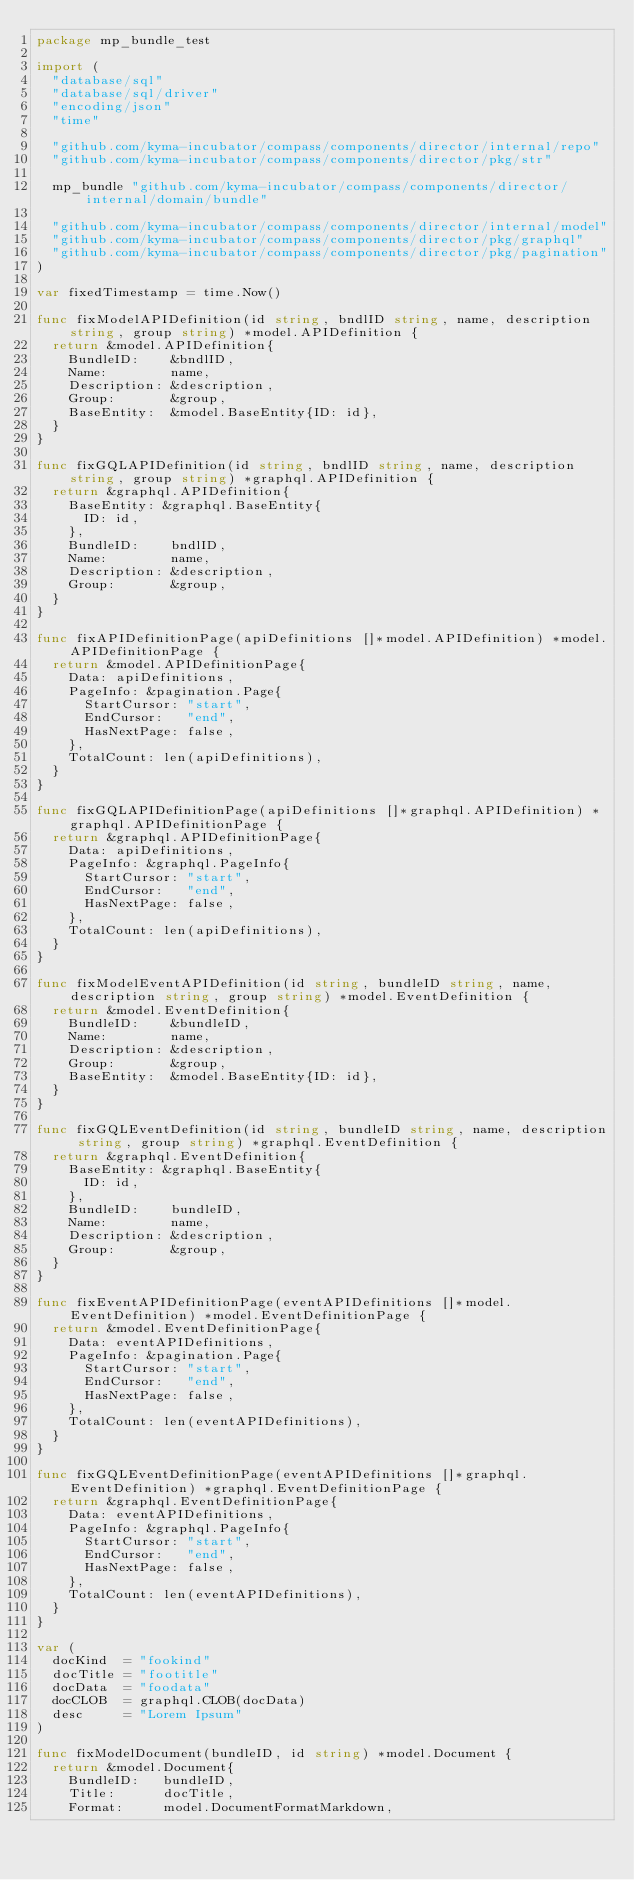Convert code to text. <code><loc_0><loc_0><loc_500><loc_500><_Go_>package mp_bundle_test

import (
	"database/sql"
	"database/sql/driver"
	"encoding/json"
	"time"

	"github.com/kyma-incubator/compass/components/director/internal/repo"
	"github.com/kyma-incubator/compass/components/director/pkg/str"

	mp_bundle "github.com/kyma-incubator/compass/components/director/internal/domain/bundle"

	"github.com/kyma-incubator/compass/components/director/internal/model"
	"github.com/kyma-incubator/compass/components/director/pkg/graphql"
	"github.com/kyma-incubator/compass/components/director/pkg/pagination"
)

var fixedTimestamp = time.Now()

func fixModelAPIDefinition(id string, bndlID string, name, description string, group string) *model.APIDefinition {
	return &model.APIDefinition{
		BundleID:    &bndlID,
		Name:        name,
		Description: &description,
		Group:       &group,
		BaseEntity:  &model.BaseEntity{ID: id},
	}
}

func fixGQLAPIDefinition(id string, bndlID string, name, description string, group string) *graphql.APIDefinition {
	return &graphql.APIDefinition{
		BaseEntity: &graphql.BaseEntity{
			ID: id,
		},
		BundleID:    bndlID,
		Name:        name,
		Description: &description,
		Group:       &group,
	}
}

func fixAPIDefinitionPage(apiDefinitions []*model.APIDefinition) *model.APIDefinitionPage {
	return &model.APIDefinitionPage{
		Data: apiDefinitions,
		PageInfo: &pagination.Page{
			StartCursor: "start",
			EndCursor:   "end",
			HasNextPage: false,
		},
		TotalCount: len(apiDefinitions),
	}
}

func fixGQLAPIDefinitionPage(apiDefinitions []*graphql.APIDefinition) *graphql.APIDefinitionPage {
	return &graphql.APIDefinitionPage{
		Data: apiDefinitions,
		PageInfo: &graphql.PageInfo{
			StartCursor: "start",
			EndCursor:   "end",
			HasNextPage: false,
		},
		TotalCount: len(apiDefinitions),
	}
}

func fixModelEventAPIDefinition(id string, bundleID string, name, description string, group string) *model.EventDefinition {
	return &model.EventDefinition{
		BundleID:    &bundleID,
		Name:        name,
		Description: &description,
		Group:       &group,
		BaseEntity:  &model.BaseEntity{ID: id},
	}
}

func fixGQLEventDefinition(id string, bundleID string, name, description string, group string) *graphql.EventDefinition {
	return &graphql.EventDefinition{
		BaseEntity: &graphql.BaseEntity{
			ID: id,
		},
		BundleID:    bundleID,
		Name:        name,
		Description: &description,
		Group:       &group,
	}
}

func fixEventAPIDefinitionPage(eventAPIDefinitions []*model.EventDefinition) *model.EventDefinitionPage {
	return &model.EventDefinitionPage{
		Data: eventAPIDefinitions,
		PageInfo: &pagination.Page{
			StartCursor: "start",
			EndCursor:   "end",
			HasNextPage: false,
		},
		TotalCount: len(eventAPIDefinitions),
	}
}

func fixGQLEventDefinitionPage(eventAPIDefinitions []*graphql.EventDefinition) *graphql.EventDefinitionPage {
	return &graphql.EventDefinitionPage{
		Data: eventAPIDefinitions,
		PageInfo: &graphql.PageInfo{
			StartCursor: "start",
			EndCursor:   "end",
			HasNextPage: false,
		},
		TotalCount: len(eventAPIDefinitions),
	}
}

var (
	docKind  = "fookind"
	docTitle = "footitle"
	docData  = "foodata"
	docCLOB  = graphql.CLOB(docData)
	desc     = "Lorem Ipsum"
)

func fixModelDocument(bundleID, id string) *model.Document {
	return &model.Document{
		BundleID:   bundleID,
		Title:      docTitle,
		Format:     model.DocumentFormatMarkdown,</code> 